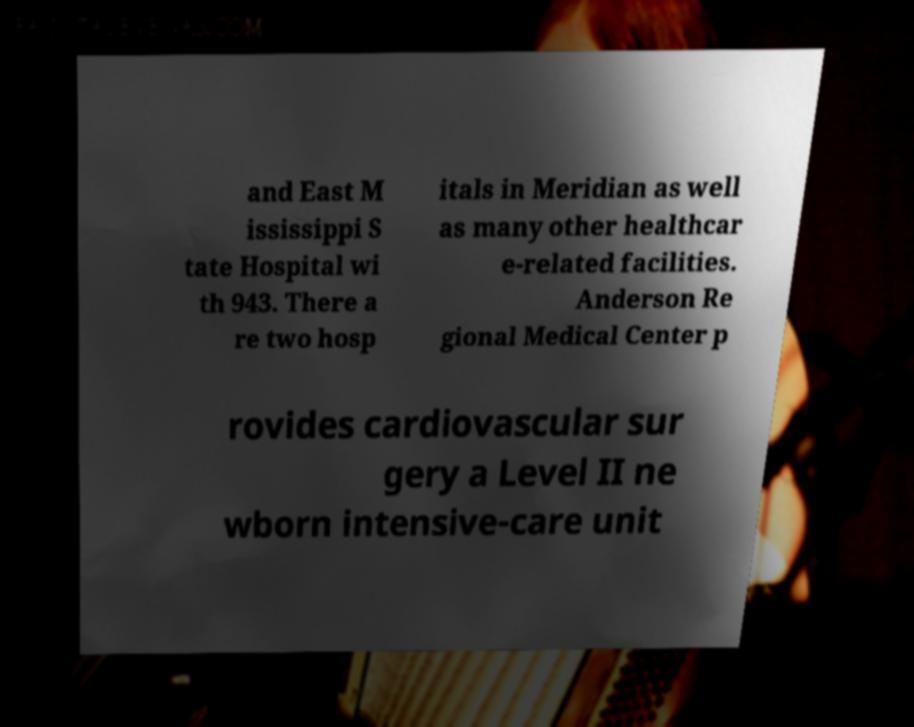Please read and relay the text visible in this image. What does it say? and East M ississippi S tate Hospital wi th 943. There a re two hosp itals in Meridian as well as many other healthcar e-related facilities. Anderson Re gional Medical Center p rovides cardiovascular sur gery a Level II ne wborn intensive-care unit 